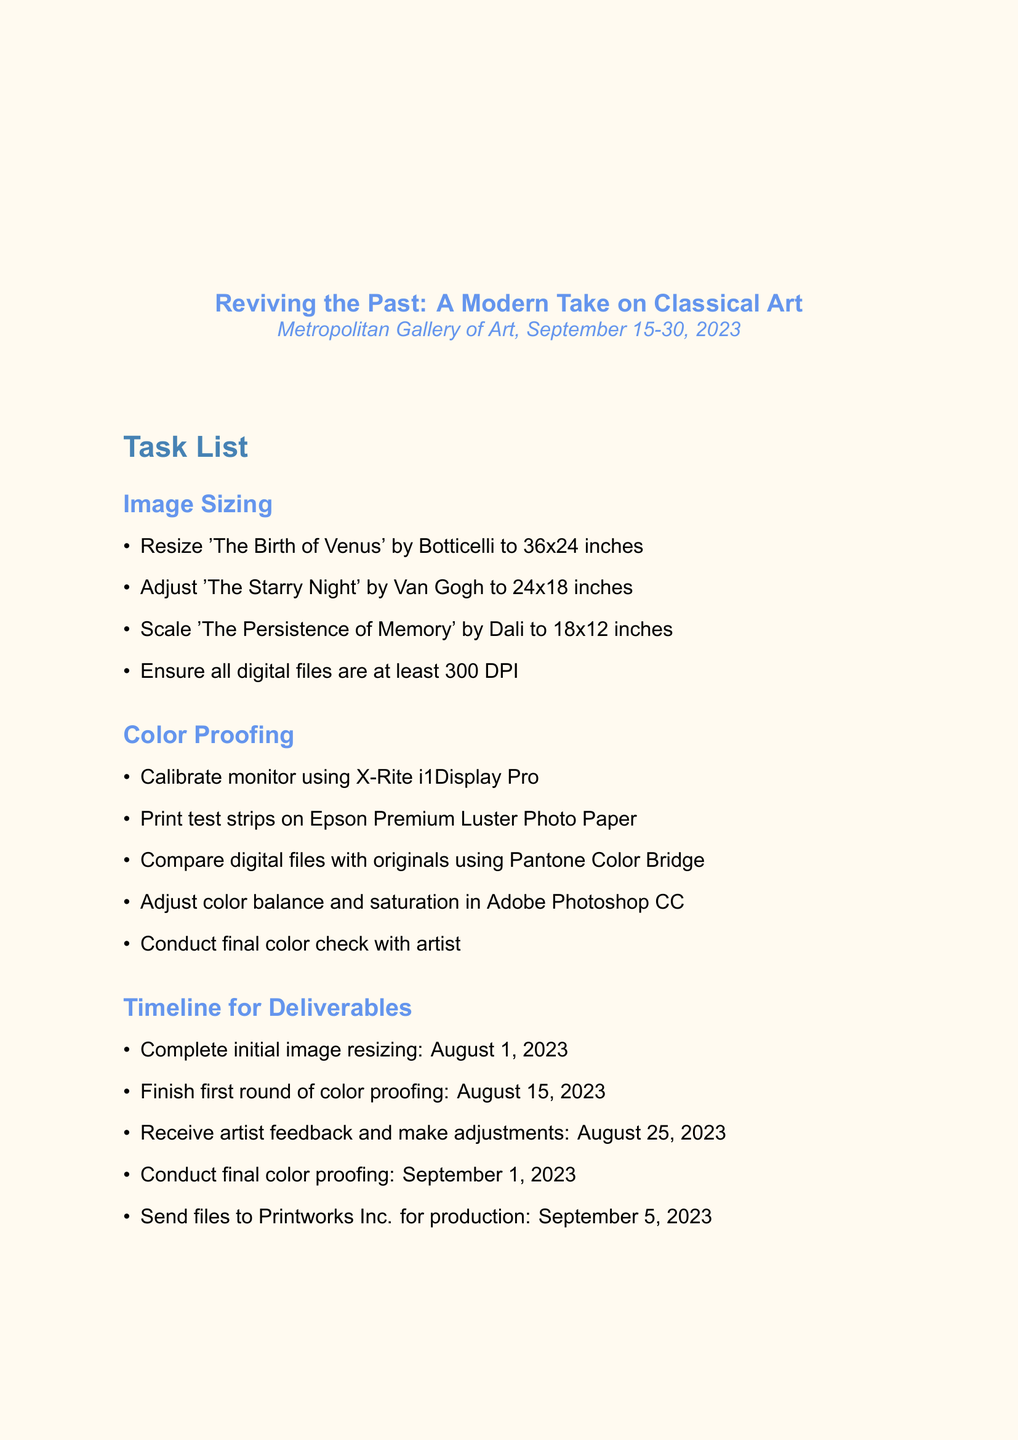What is the name of the exhibition? The name of the exhibition is specified in the document, titled "Reviving the Past: A Modern Take on Classical Art."
Answer: Reviving the Past: A Modern Take on Classical Art Who is the curator of the exhibition? The curator's name is mentioned in the document under exhibition details.
Answer: Dr. Emily Fitzgerald What is the size for 'The Starry Night' by Van Gogh? The size required for 'The Starry Night' is outlined in the image sizing section of the document.
Answer: 24x18 inches When is the final color proofing due? The deadline for final color proofing is stated in the timeline for deliverables section of the document.
Answer: September 1, 2023 What equipment is required for the exhibition? The document lists the necessary equipment explicitly.
Answer: Dell UltraSharp UP3218K 8K Monitor, Epson SureColor P900 17-Inch Printer, X-Rite i1Display Pro Colorimeter, Wacom Intuos Pro Large Graphics Tablet How many tasks are listed under Color Proofing? The number of tasks can be counted from the color proofing section in the document.
Answer: 5 What software is used for color balance adjustments? The software used for color balance adjustments is identified in the document.
Answer: Adobe Photoshop CC What is the communication method for technical challenges? The document specifies communication methods under collaboration notes.
Answer: Slack 